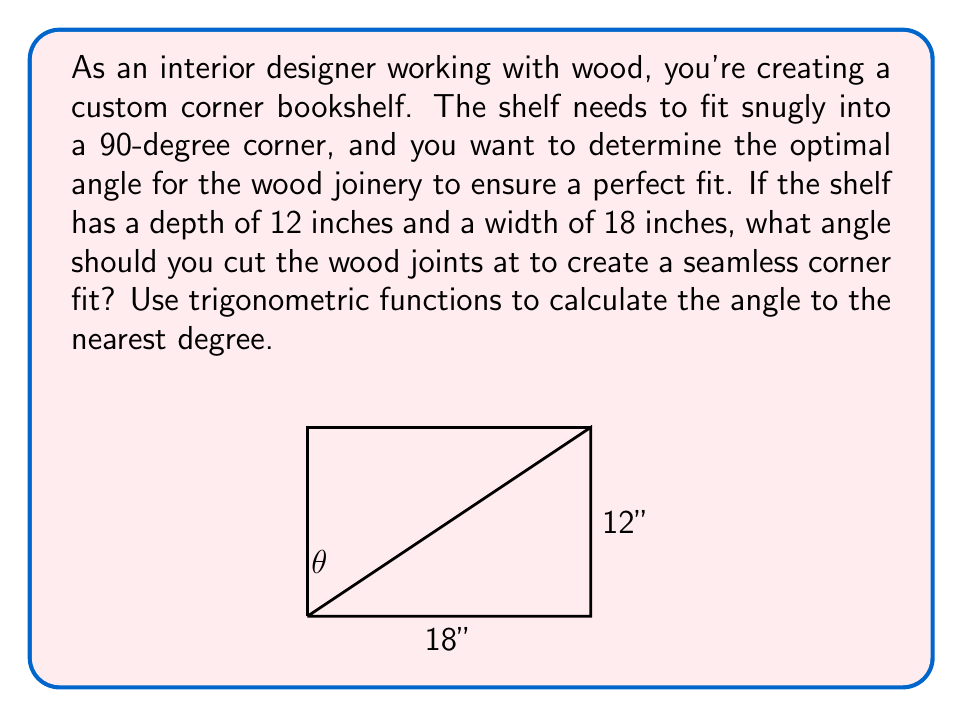Can you answer this question? To solve this problem, we need to use the arctangent function to find the angle $\theta$ in the right triangle formed by the corner shelf.

1) First, let's identify the sides of the right triangle:
   - The base (adjacent to $\theta$) is 18 inches
   - The height (opposite to $\theta$) is 12 inches

2) We can use the tangent function to find $\theta$:

   $\tan(\theta) = \frac{\text{opposite}}{\text{adjacent}} = \frac{12}{18} = \frac{2}{3}$

3) To find $\theta$, we need to use the inverse tangent (arctangent) function:

   $\theta = \arctan(\frac{2}{3})$

4) Using a calculator or computer, we can evaluate this:

   $\theta \approx 33.69$ degrees

5) Rounding to the nearest degree:

   $\theta \approx 34$ degrees

6) However, this is only half of the angle we need to cut. Since we want the two pieces to fit together in a 90-degree corner, we need to cut each piece at half of the complement of this angle:

   Complement of $\theta = 90° - 34° = 56°$
   
   Half of the complement $= 56° \div 2 = 28°$

Therefore, you should cut each wood joint at a 28-degree angle to create a seamless 90-degree corner fit.
Answer: The optimal angle for cutting the wood joints is 28 degrees. 